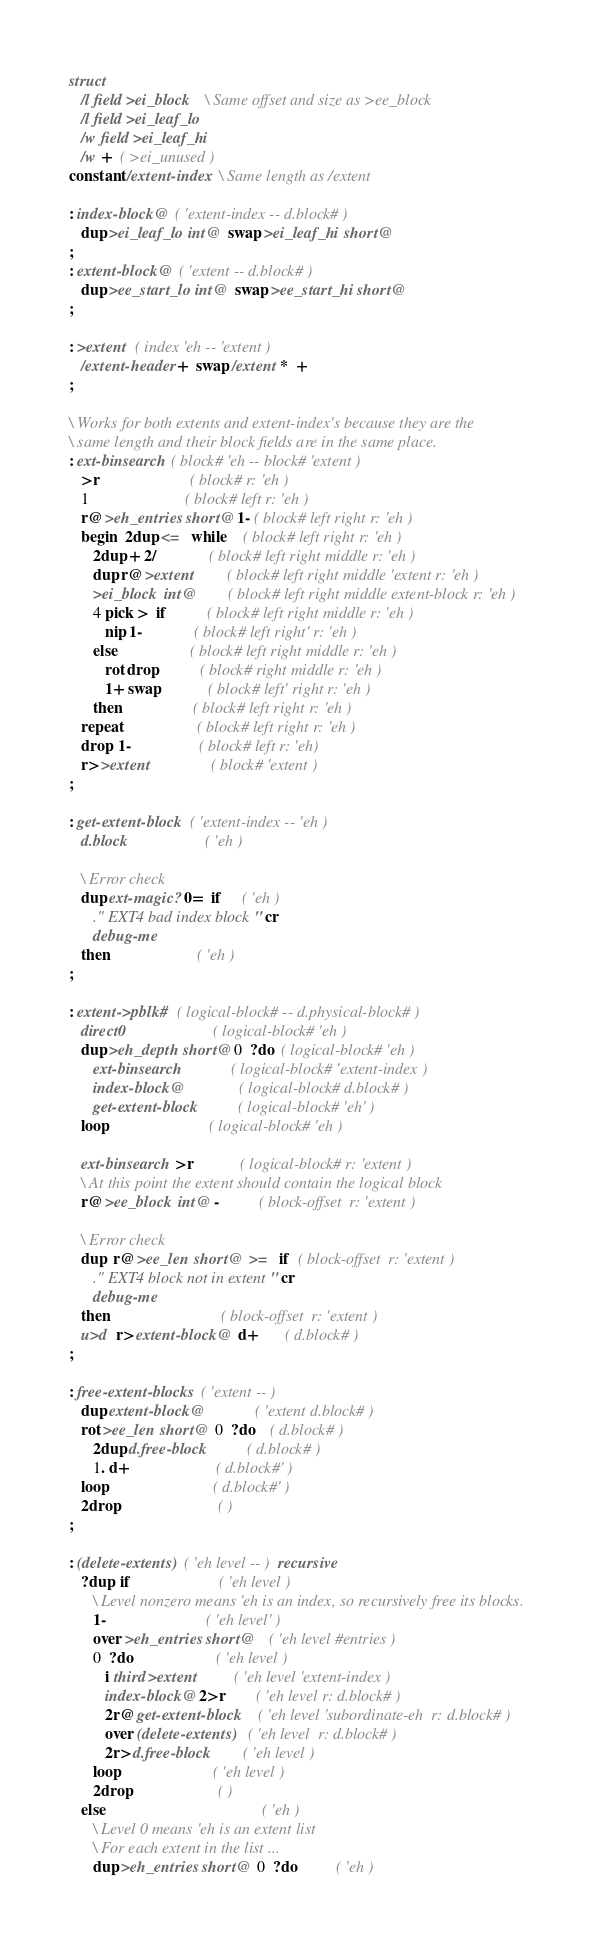<code> <loc_0><loc_0><loc_500><loc_500><_Forth_>struct
   /l field >ei_block   \ Same offset and size as >ee_block
   /l field >ei_leaf_lo
   /w field >ei_leaf_hi
   /w +  ( >ei_unused )
constant /extent-index  \ Same length as /extent

: index-block@  ( 'extent-index -- d.block# )
   dup >ei_leaf_lo int@  swap >ei_leaf_hi short@
;
: extent-block@  ( 'extent -- d.block# )
   dup >ee_start_lo int@  swap >ee_start_hi short@
;

: >extent  ( index 'eh -- 'extent )
   /extent-header +  swap /extent *  +
;

\ Works for both extents and extent-index's because they are the
\ same length and their block fields are in the same place.
: ext-binsearch  ( block# 'eh -- block# 'extent )
   >r                       ( block# r: 'eh )
   1                        ( block# left r: 'eh )
   r@ >eh_entries short@ 1- ( block# left right r: 'eh )
   begin  2dup <=  while    ( block# left right r: 'eh )
      2dup + 2/             ( block# left right middle r: 'eh )
      dup r@ >extent        ( block# left right middle 'extent r: 'eh )
      >ei_block int@        ( block# left right middle extent-block r: 'eh )
      4 pick >  if          ( block# left right middle r: 'eh )
         nip 1-             ( block# left right' r: 'eh )
      else                  ( block# left right middle r: 'eh )
         rot drop           ( block# right middle r: 'eh )
         1+ swap            ( block# left' right r: 'eh )
      then                  ( block# left right r: 'eh )
   repeat                   ( block# left right r: 'eh )
   drop  1-                 ( block# left r: 'eh)
   r> >extent               ( block# 'extent )
;

: get-extent-block  ( 'extent-index -- 'eh )
   d.block                   ( 'eh )

   \ Error check
   dup ext-magic? 0=  if     ( 'eh )
      ." EXT4 bad index block" cr
      debug-me
   then                      ( 'eh )
;

: extent->pblk#  ( logical-block# -- d.physical-block# )
   direct0                      ( logical-block# 'eh )
   dup >eh_depth short@ 0  ?do  ( logical-block# 'eh )
      ext-binsearch             ( logical-block# 'extent-index )
      index-block@              ( logical-block# d.block# )
      get-extent-block          ( logical-block# 'eh' )
   loop                         ( logical-block# 'eh )

   ext-binsearch  >r            ( logical-block# r: 'extent )
   \ At this point the extent should contain the logical block
   r@ >ee_block int@ -          ( block-offset  r: 'extent )
   
   \ Error check
   dup  r@ >ee_len short@  >=  if  ( block-offset  r: 'extent )
      ." EXT4 block not in extent" cr
      debug-me
   then                            ( block-offset  r: 'extent )
   u>d  r> extent-block@  d+       ( d.block# )
;

: free-extent-blocks  ( 'extent -- )
   dup extent-block@             ( 'extent d.block# )
   rot >ee_len short@  0  ?do    ( d.block# )
      2dup d.free-block          ( d.block# )
      1. d+                      ( d.block#' )
   loop                          ( d.block#' )
   2drop                         ( )
;

: (delete-extents)  ( 'eh level -- )  recursive
   ?dup  if                      ( 'eh level )
      \ Level nonzero means 'eh is an index, so recursively free its blocks.
      1-                         ( 'eh level' )
      over >eh_entries short@    ( 'eh level #entries )
      0  ?do                     ( 'eh level )
         i third >extent         ( 'eh level 'extent-index )
         index-block@ 2>r        ( 'eh level r: d.block# )
         2r@ get-extent-block    ( 'eh level 'subordinate-eh  r: d.block# )
         over (delete-extents)   ( 'eh level  r: d.block# )
         2r> d.free-block        ( 'eh level )
      loop                       ( 'eh level )
      2drop                      ( )
   else                                       ( 'eh )
      \ Level 0 means 'eh is an extent list
      \ For each extent in the list ...
      dup >eh_entries short@  0  ?do          ( 'eh )</code> 